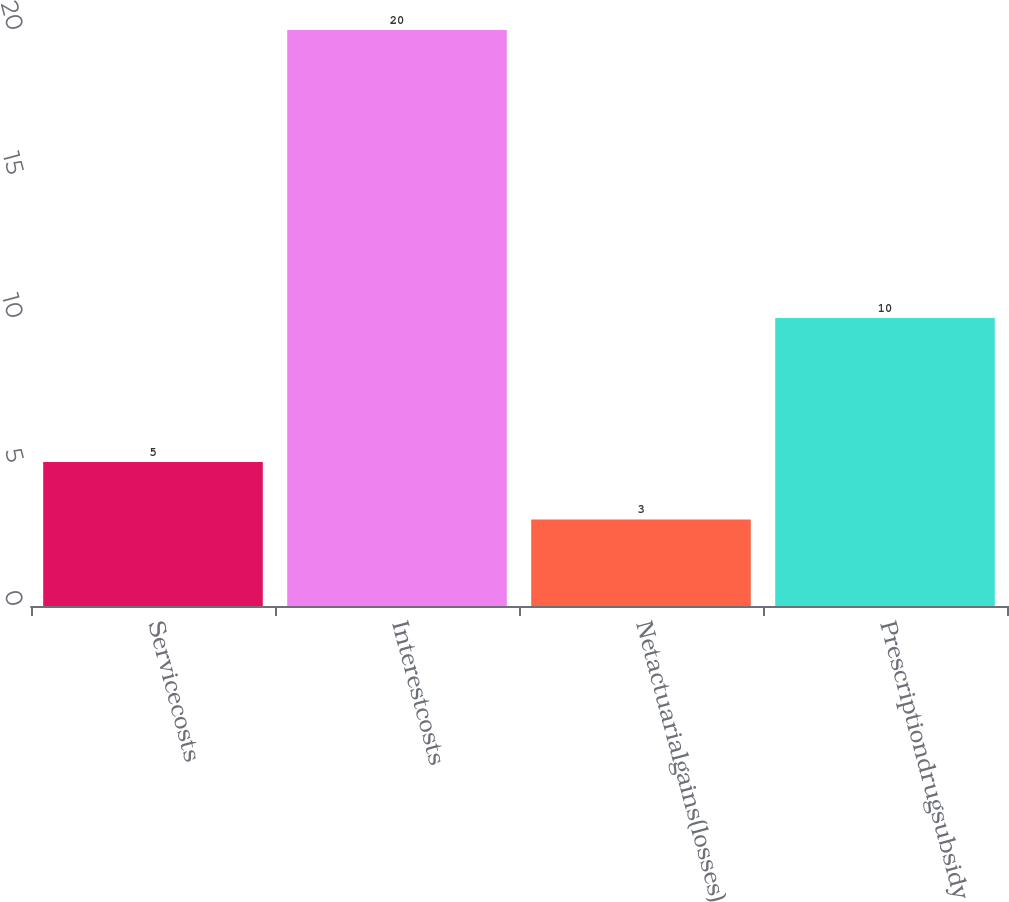Convert chart. <chart><loc_0><loc_0><loc_500><loc_500><bar_chart><fcel>Servicecosts<fcel>Interestcosts<fcel>Netactuarialgains(losses)<fcel>Prescriptiondrugsubsidy<nl><fcel>5<fcel>20<fcel>3<fcel>10<nl></chart> 